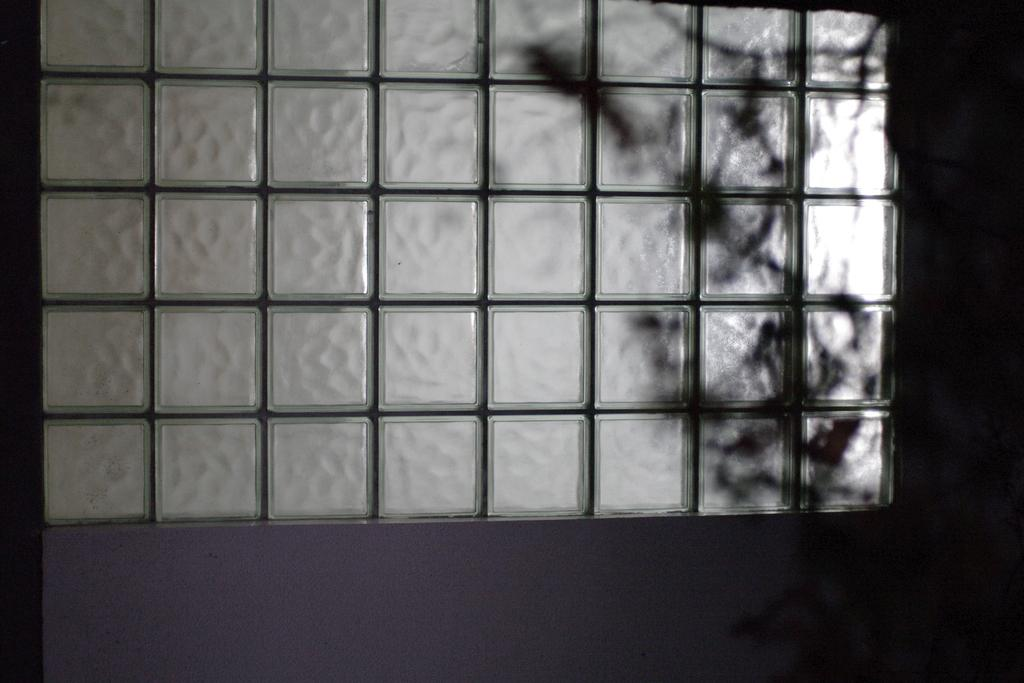What is present on the right side of the image? There is a shadow on the right side of the image. What can be seen on the left side of the image? The facts provided do not specify anything on the left side of the image. What is the main structure or feature in the image? There is a wall in the image. What type of oatmeal is being used to support the boundary in the image? There is no oatmeal or boundary present in the image. What type of support is provided by the oatmeal in the image? There is no oatmeal present in the image, so it cannot provide any support. 